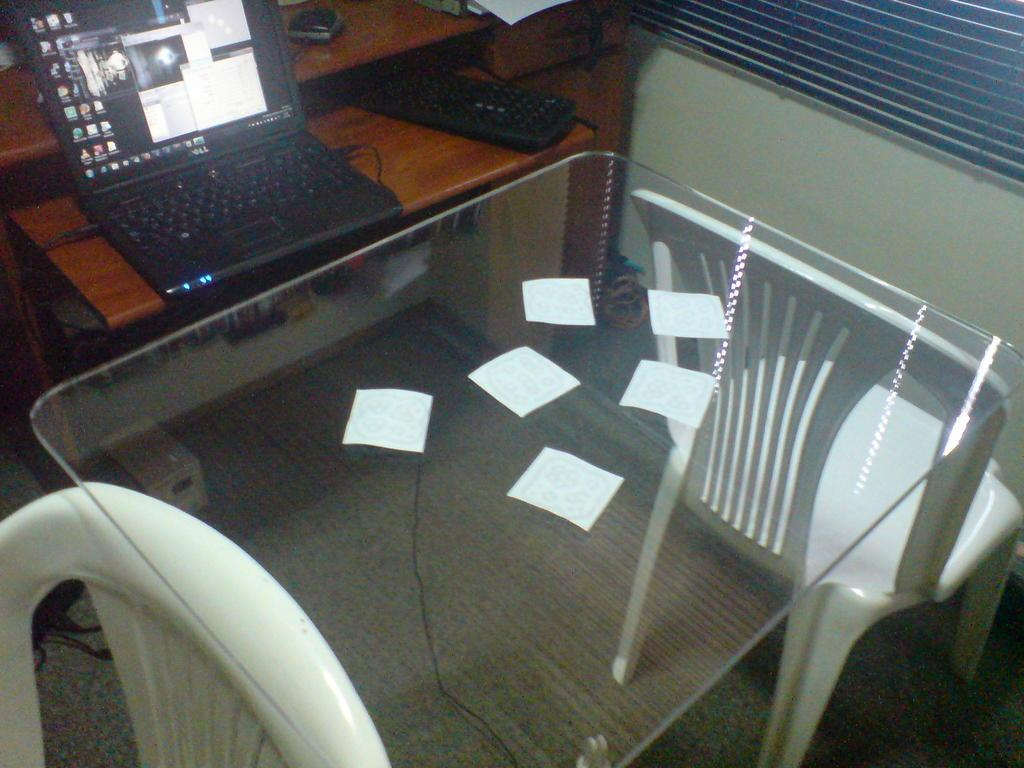What type of furniture is present in the room? There is a table and chairs in the room. What electronic device can be seen on a piece of furniture? There is a laptop on a piece of furniture. What accessories are present for the laptop? There is a keyboard and a mouse on the furniture. What type of copper frame is visible around the laptop in the image? There is no copper frame visible around the laptop in the image. What route is the laptop taking in the room? The laptop is stationary on a piece of furniture and does not have a route in the room. 